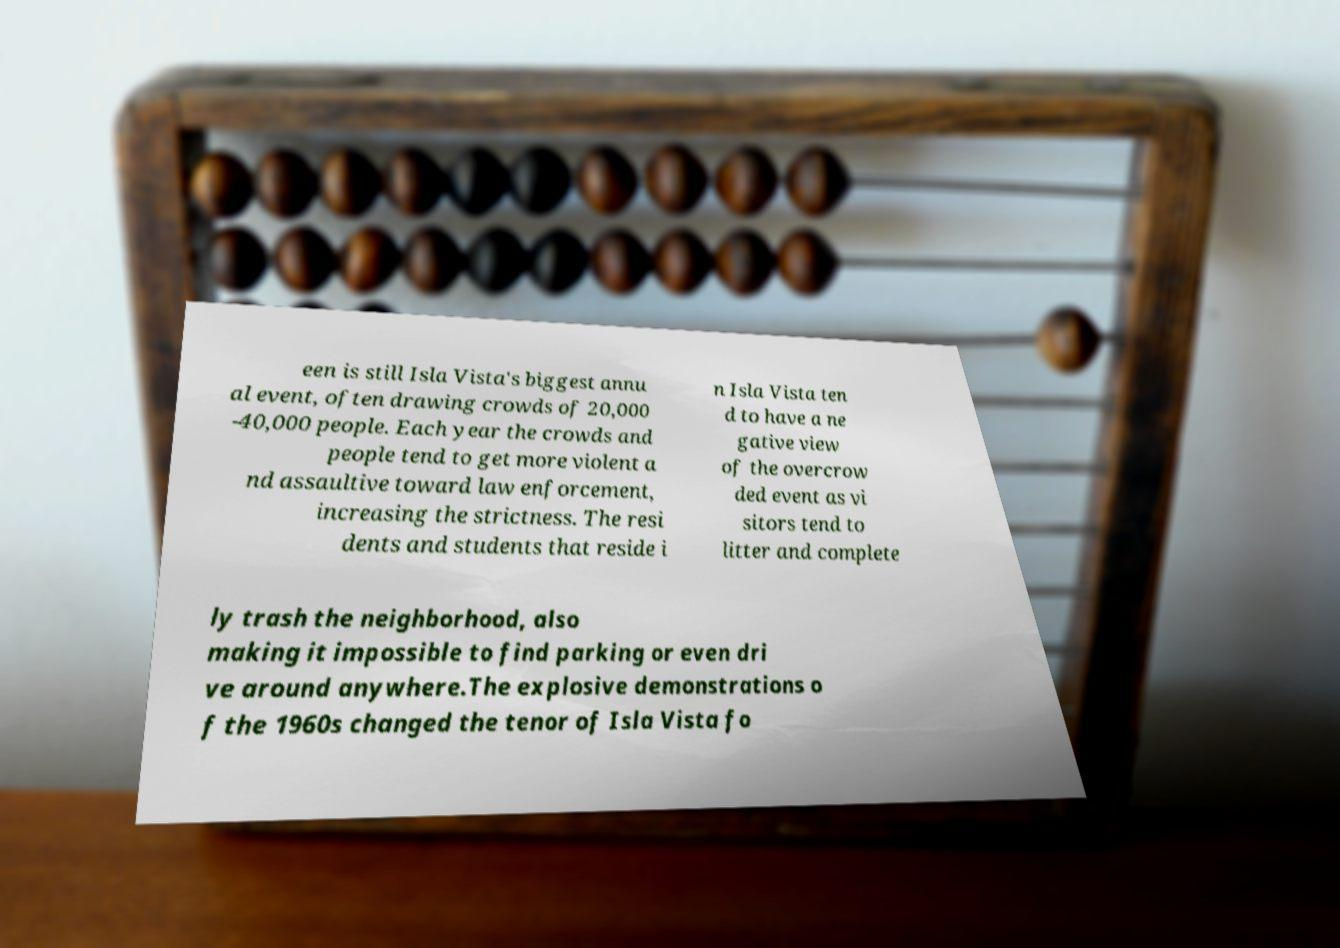Please identify and transcribe the text found in this image. een is still Isla Vista's biggest annu al event, often drawing crowds of 20,000 -40,000 people. Each year the crowds and people tend to get more violent a nd assaultive toward law enforcement, increasing the strictness. The resi dents and students that reside i n Isla Vista ten d to have a ne gative view of the overcrow ded event as vi sitors tend to litter and complete ly trash the neighborhood, also making it impossible to find parking or even dri ve around anywhere.The explosive demonstrations o f the 1960s changed the tenor of Isla Vista fo 